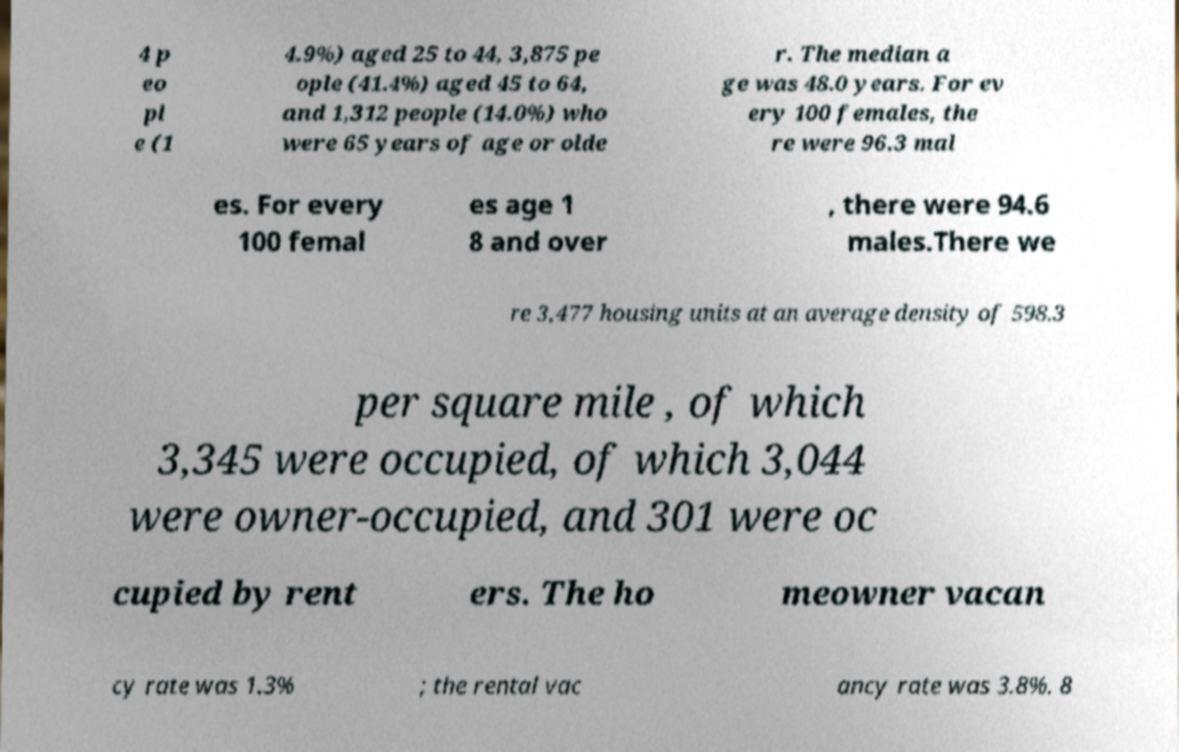I need the written content from this picture converted into text. Can you do that? 4 p eo pl e (1 4.9%) aged 25 to 44, 3,875 pe ople (41.4%) aged 45 to 64, and 1,312 people (14.0%) who were 65 years of age or olde r. The median a ge was 48.0 years. For ev ery 100 females, the re were 96.3 mal es. For every 100 femal es age 1 8 and over , there were 94.6 males.There we re 3,477 housing units at an average density of 598.3 per square mile , of which 3,345 were occupied, of which 3,044 were owner-occupied, and 301 were oc cupied by rent ers. The ho meowner vacan cy rate was 1.3% ; the rental vac ancy rate was 3.8%. 8 